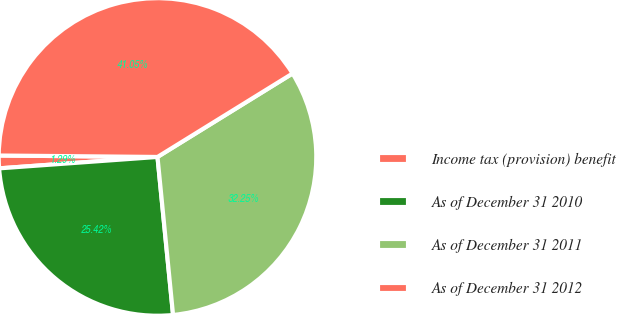Convert chart. <chart><loc_0><loc_0><loc_500><loc_500><pie_chart><fcel>Income tax (provision) benefit<fcel>As of December 31 2010<fcel>As of December 31 2011<fcel>As of December 31 2012<nl><fcel>1.29%<fcel>25.42%<fcel>32.25%<fcel>41.05%<nl></chart> 